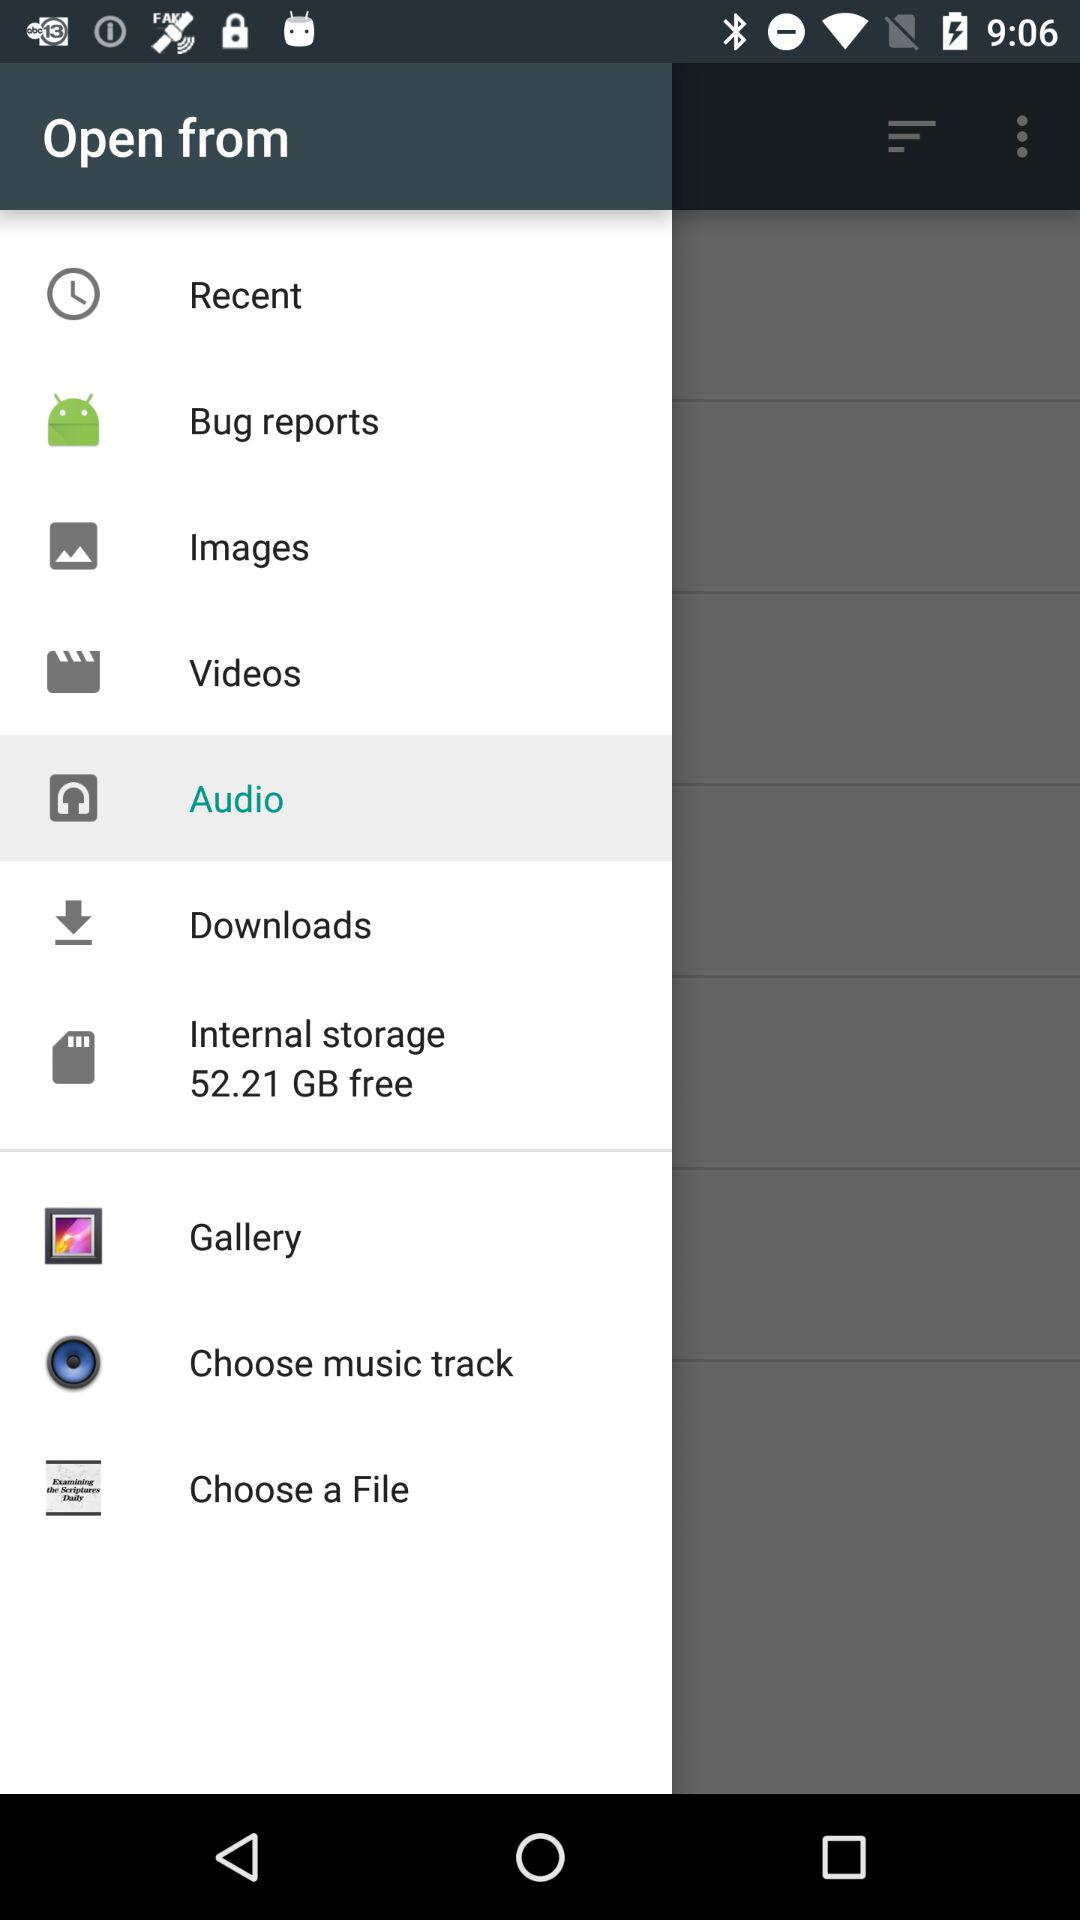How much internal storage is used?
When the provided information is insufficient, respond with <no answer>. <no answer> 